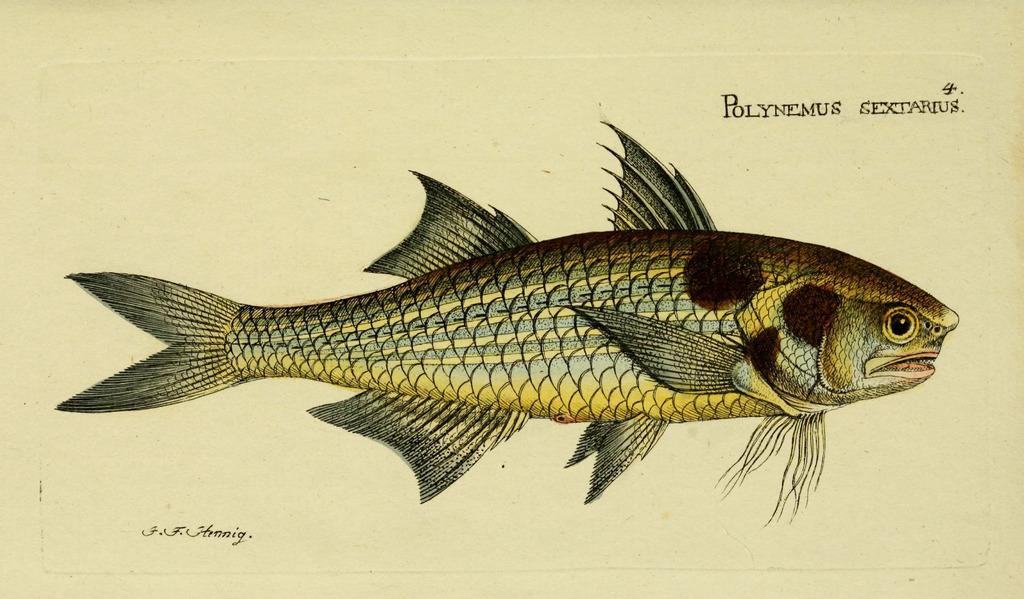What is depicted on the white paper in the image? There is a drawing of a fish on a white paper. What else can be seen in the image besides the drawing of the fish? There is some text in the image. What invention is being demonstrated in the image? There is no invention being demonstrated in the image; it features a drawing of a fish and some text. How many times does the wave appear in the image? There is no wave present in the image; it only contains a drawing of a fish and some text. 